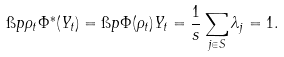Convert formula to latex. <formula><loc_0><loc_0><loc_500><loc_500>\i p { \rho _ { t } } { \Phi ^ { \ast } ( Y _ { t } ) } = \i p { \Phi ( \rho _ { t } ) } { Y _ { t } } = \frac { 1 } { s } \sum _ { j \in S } \lambda _ { j } = 1 .</formula> 